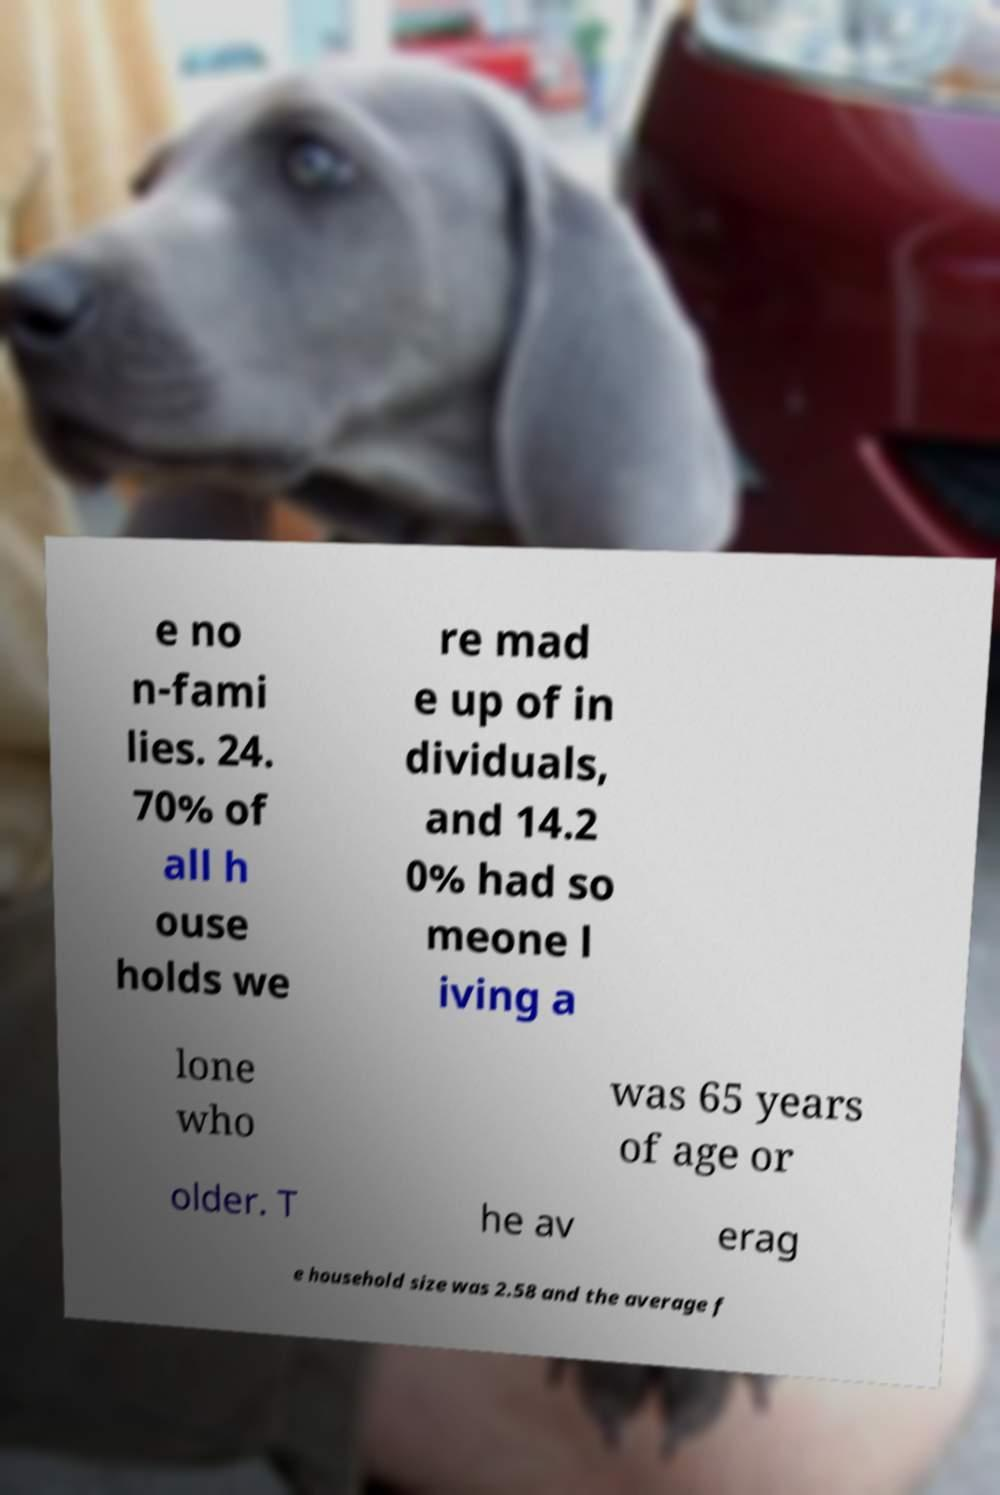Can you read and provide the text displayed in the image?This photo seems to have some interesting text. Can you extract and type it out for me? e no n-fami lies. 24. 70% of all h ouse holds we re mad e up of in dividuals, and 14.2 0% had so meone l iving a lone who was 65 years of age or older. T he av erag e household size was 2.58 and the average f 